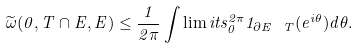<formula> <loc_0><loc_0><loc_500><loc_500>\widetilde { \omega } ( 0 , T \cap E , E ) \leq \frac { 1 } { 2 \pi } \int \lim i t s _ { 0 } ^ { 2 \pi } 1 _ { \partial E \ T } ( e ^ { i \theta } ) d \theta .</formula> 